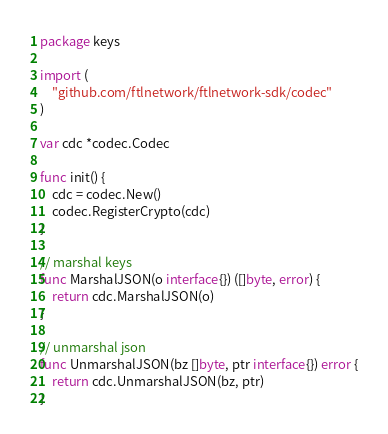Convert code to text. <code><loc_0><loc_0><loc_500><loc_500><_Go_>package keys

import (
	"github.com/ftlnetwork/ftlnetwork-sdk/codec"
)

var cdc *codec.Codec

func init() {
	cdc = codec.New()
	codec.RegisterCrypto(cdc)
}

// marshal keys
func MarshalJSON(o interface{}) ([]byte, error) {
	return cdc.MarshalJSON(o)
}

// unmarshal json
func UnmarshalJSON(bz []byte, ptr interface{}) error {
	return cdc.UnmarshalJSON(bz, ptr)
}
</code> 